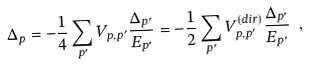Convert formula to latex. <formula><loc_0><loc_0><loc_500><loc_500>\Delta _ { p } = - \frac { 1 } { 4 } \sum _ { p ^ { \prime } } V _ { p , p ^ { \prime } } \frac { \Delta _ { p ^ { \prime } } } { E _ { p ^ { \prime } } } = - \frac { 1 } { 2 } \sum _ { p ^ { \prime } } V _ { p , p ^ { \prime } } ^ { ( d i r ) } \frac { \Delta _ { p ^ { \prime } } } { E _ { p ^ { \prime } } } \ ,</formula> 